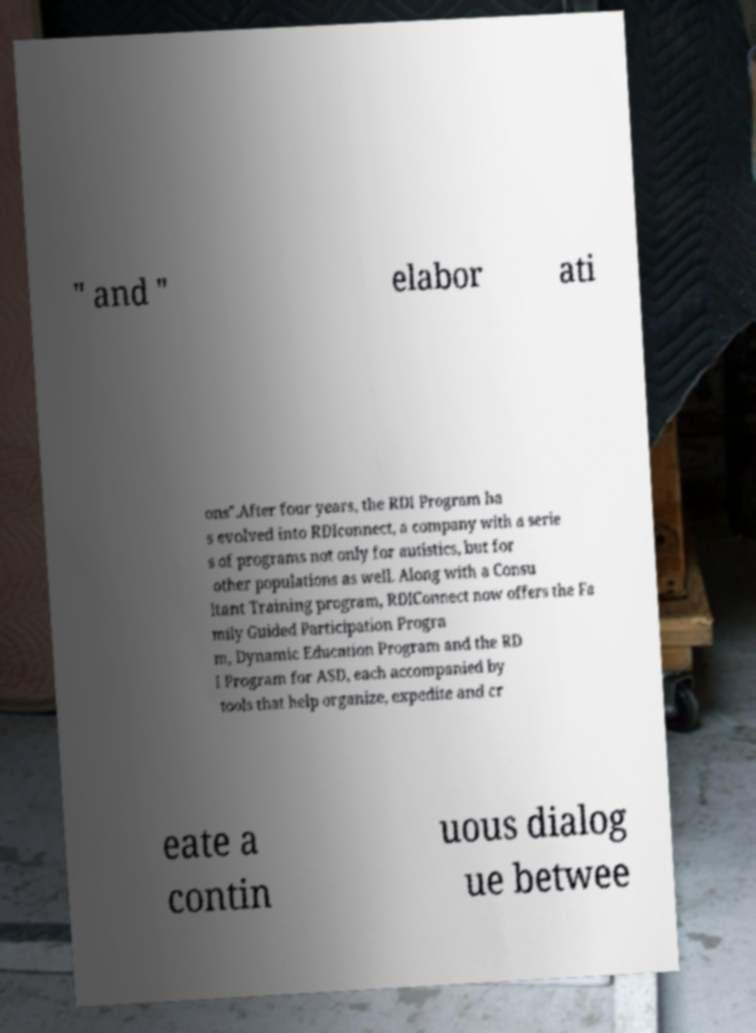What messages or text are displayed in this image? I need them in a readable, typed format. " and " elabor ati ons".After four years, the RDI Program ha s evolved into RDIconnect, a company with a serie s of programs not only for autistics, but for other populations as well. Along with a Consu ltant Training program, RDIConnect now offers the Fa mily Guided Participation Progra m, Dynamic Education Program and the RD I Program for ASD, each accompanied by tools that help organize, expedite and cr eate a contin uous dialog ue betwee 